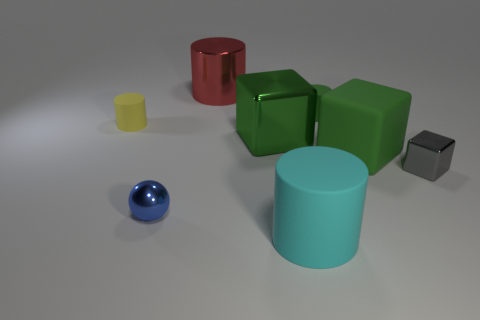There is a large metal object to the right of the large red metal cylinder; what is its shape?
Give a very brief answer. Cube. What number of gray rubber objects are the same shape as the small green matte object?
Give a very brief answer. 0. Is the number of big red shiny cylinders in front of the big green matte thing the same as the number of matte things on the left side of the small blue metallic thing?
Ensure brevity in your answer.  No. Is there a small yellow cylinder made of the same material as the small block?
Provide a succinct answer. No. Is the material of the large cyan cylinder the same as the small yellow thing?
Give a very brief answer. Yes. How many blue objects are rubber cylinders or small objects?
Offer a terse response. 1. Is the number of tiny blue things that are behind the large red object greater than the number of red metallic cylinders?
Ensure brevity in your answer.  No. Are there any cylinders that have the same color as the matte cube?
Make the answer very short. Yes. What size is the cyan rubber cylinder?
Offer a terse response. Large. Do the rubber cube and the big metallic cube have the same color?
Keep it short and to the point. Yes. 